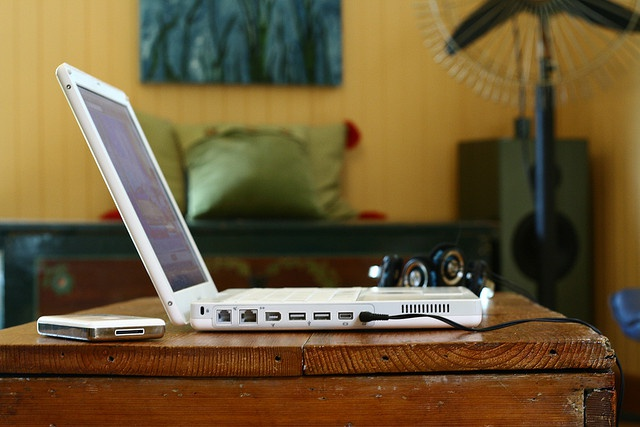Describe the objects in this image and their specific colors. I can see laptop in tan, lightgray, darkgray, gray, and black tones and cell phone in tan, white, gray, and maroon tones in this image. 